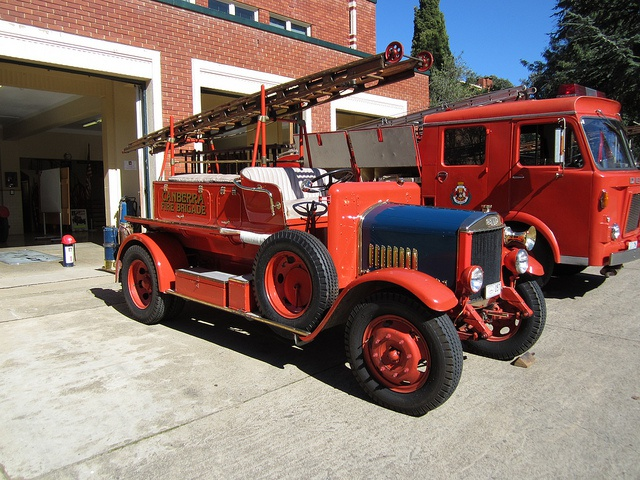Describe the objects in this image and their specific colors. I can see truck in salmon, black, maroon, brown, and red tones and truck in salmon, maroon, black, brown, and gray tones in this image. 